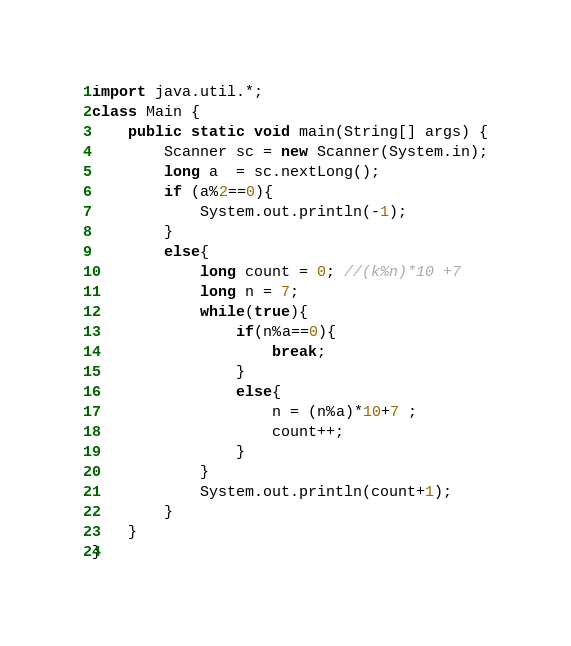<code> <loc_0><loc_0><loc_500><loc_500><_Java_>import java.util.*;
class Main {
    public static void main(String[] args) {
        Scanner sc = new Scanner(System.in);
        long a  = sc.nextLong();
        if (a%2==0){
            System.out.println(-1);
        }
        else{
            long count = 0; //(k%n)*10 +7
            long n = 7;
            while(true){
                if(n%a==0){
                    break;
                }
                else{  
                    n = (n%a)*10+7 ;
                    count++;
                }
            }
            System.out.println(count+1);
        }
    }
}</code> 